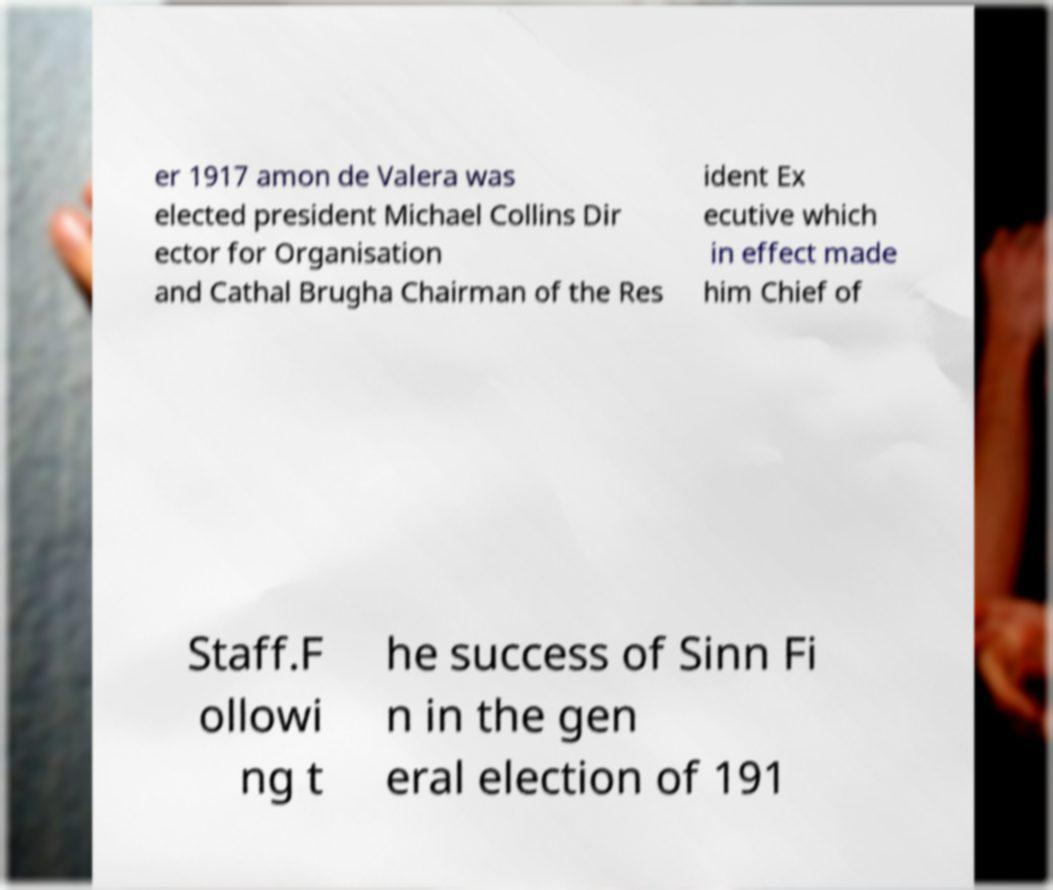Could you extract and type out the text from this image? er 1917 amon de Valera was elected president Michael Collins Dir ector for Organisation and Cathal Brugha Chairman of the Res ident Ex ecutive which in effect made him Chief of Staff.F ollowi ng t he success of Sinn Fi n in the gen eral election of 191 